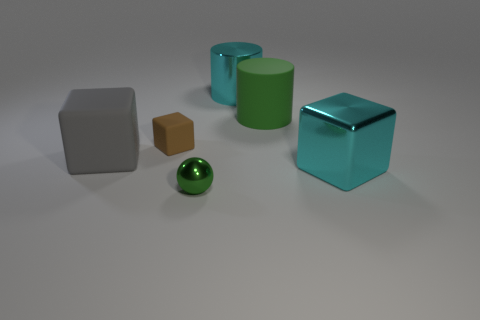What number of other things are the same shape as the brown object?
Make the answer very short. 2. What size is the green thing that is made of the same material as the large gray block?
Provide a short and direct response. Large. Is the material of the tiny object right of the brown thing the same as the cube in front of the big gray cube?
Give a very brief answer. Yes. What number of balls are green rubber objects or small brown objects?
Ensure brevity in your answer.  0. There is a small green thing in front of the cyan shiny object behind the big matte block; what number of gray things are in front of it?
Offer a very short reply. 0. There is another cyan object that is the same shape as the small rubber object; what material is it?
Your answer should be very brief. Metal. Are there any other things that are made of the same material as the tiny green sphere?
Offer a terse response. Yes. What color is the matte thing that is right of the tiny green metal sphere?
Provide a succinct answer. Green. Is the material of the green ball the same as the large cyan object that is behind the big cyan metallic block?
Give a very brief answer. Yes. What material is the tiny brown cube?
Make the answer very short. Rubber. 